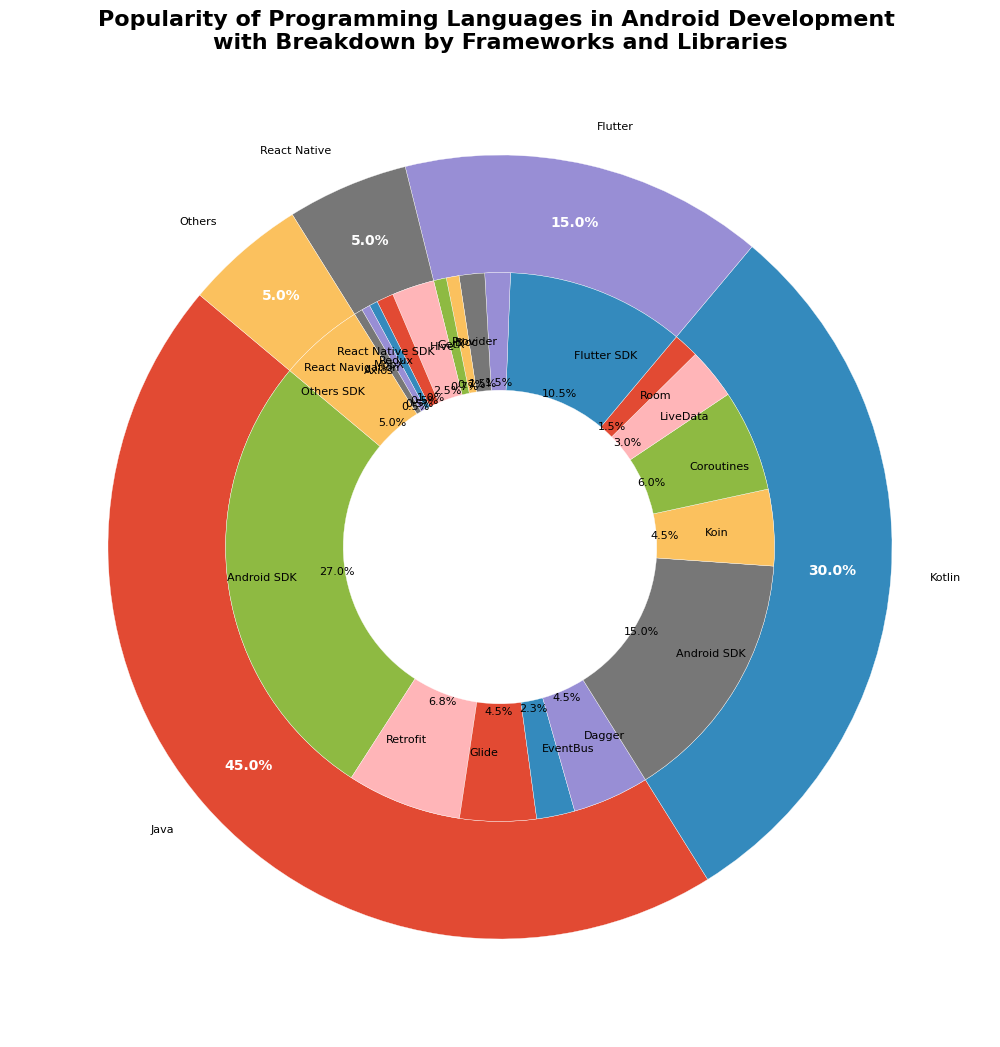Which programming language is the most popular for Android development? By looking at the largest segment in the outer ring of the pie chart, we can see the percentage values. The language with the highest percentage is the most popular.
Answer: Java What is the percentage of Kotlin usage in Android development? The outer ring of the pie chart shows the different languages used. The segment labeled "Kotlin" indicates its percentage.
Answer: 30% How does the percentage use of Flutter compare to React Native in Android development? Focus on the outer ring and compare the sizes of the segments labeled "Flutter" and "React Native". The percentage values are displayed next to each label.
Answer: Flutter usage (15%) is higher than React Native usage (5%) What percentage of Java projects use Retrofit? Look at the segment for Java in the outer ring and find the corresponding inner segment labeled "Retrofit". The percentage is displayed within this segment.
Answer: 15% Which framework or library has the highest usage within Flutter projects? Examine the inner segments within the Flutter section. Identify the segment with the highest percentage.
Answer: Flutter SDK What is the total percentage of projects using Android SDK across all languages? Sum up the percentages of Android SDK usage within both Java and Kotlin segments. Java: 60% of 45%, Kotlin: 50% of 30%. Calculate (0.6 * 45%) + (0.5 * 30%).
Answer: 37.5% Which language has the smallest proportion in Android development, and what is its percentage? Observe the outer ring for the segment with the smallest size labeled by language, and note the percentage next to it.
Answer: React Native, 5% What is the combined percentage usage of EventBus and Dagger within Java projects? Focus on the inner segments within the Java section and sum the percentages labeled "EventBus" and "Dagger". EventBus: 5%, Dagger: 10%.
Answer: 15% In Kotlin projects, how does the usage of Coroutines compare to Room? Compare the inner segments within the Kotlin section labeled "Coroutines" and "Room". Note their respective percentages.
Answer: Coroutines usage (20%) is greater than Room usage (5%) How many frameworks/libraries are used within React Native projects? Count the number of inner segments within the React Native section. Each segment represents a framework/library.
Answer: 5 